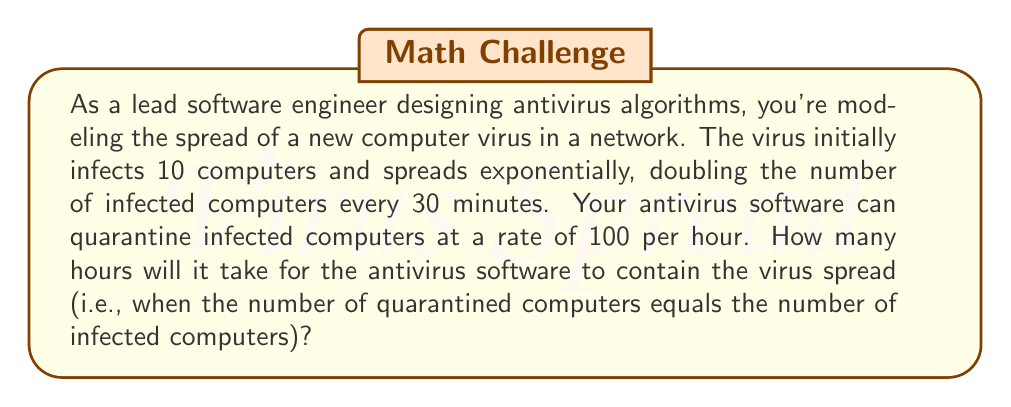Give your solution to this math problem. Let's approach this step-by-step:

1) First, we need to model the virus spread. The number of infected computers at time $t$ (in hours) is given by:

   $$I(t) = 10 \cdot 2^{2t}$$

   Here, $10$ is the initial number of infected computers, and we use $2t$ in the exponent because the virus doubles every 30 minutes (2 times per hour).

2) The number of quarantined computers at time $t$ is given by:

   $$Q(t) = 100t$$

   This is because the antivirus software quarantines 100 computers per hour.

3) We need to find when these two functions are equal:

   $$10 \cdot 2^{2t} = 100t$$

4) This equation can't be solved algebraically, so we need to use numerical methods or graphing. Let's set up a table of values:

   | t (hours) | I(t) | Q(t) |
   |-----------|------|------|
   | 1         | 40   | 100  |
   | 2         | 160  | 200  |
   | 3         | 640  | 300  |
   | 4         | 2560 | 400  |

5) We can see that somewhere between 3 and 4 hours, the number of infected computers will equal the number of quarantined computers.

6) Using a graphing calculator or computer software, we can find that the intersection occurs at approximately $t = 3.37$ hours.
Answer: It will take approximately 3.37 hours for the antivirus software to contain the virus spread. 